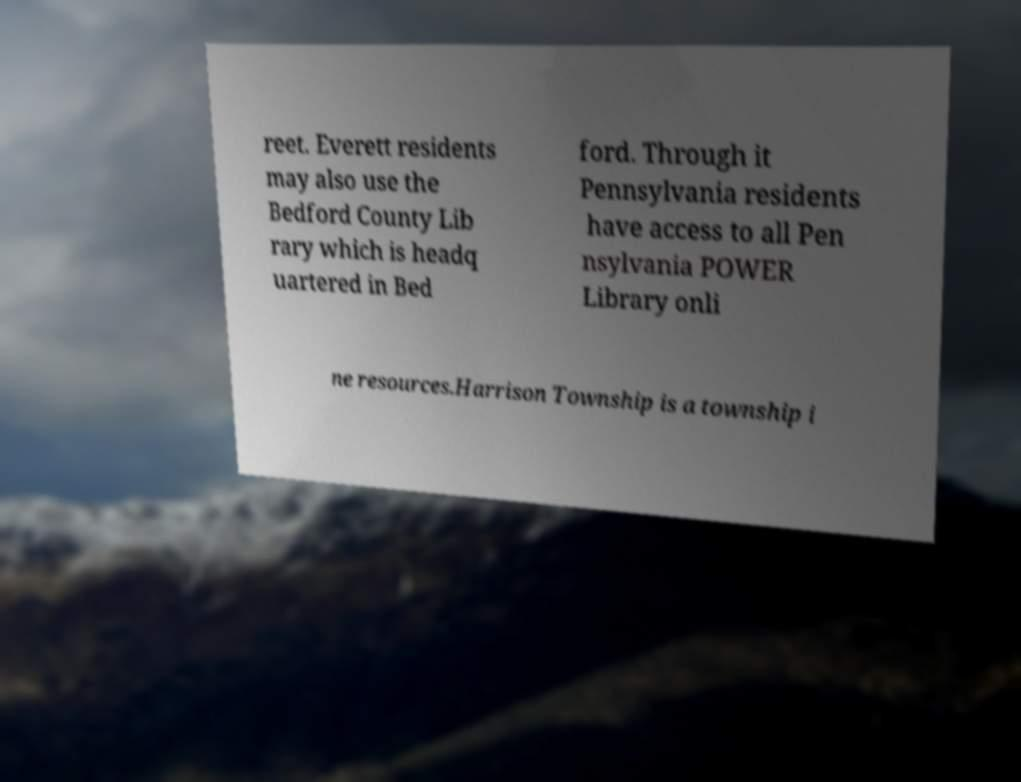I need the written content from this picture converted into text. Can you do that? reet. Everett residents may also use the Bedford County Lib rary which is headq uartered in Bed ford. Through it Pennsylvania residents have access to all Pen nsylvania POWER Library onli ne resources.Harrison Township is a township i 